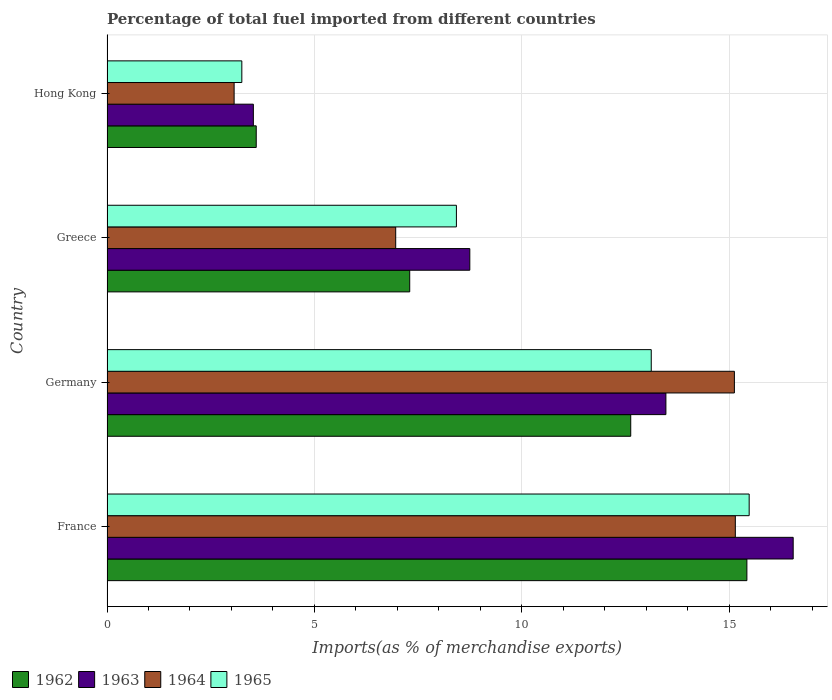How many different coloured bars are there?
Ensure brevity in your answer.  4. How many bars are there on the 2nd tick from the top?
Your answer should be very brief. 4. What is the label of the 1st group of bars from the top?
Make the answer very short. Hong Kong. What is the percentage of imports to different countries in 1965 in Germany?
Provide a short and direct response. 13.12. Across all countries, what is the maximum percentage of imports to different countries in 1965?
Make the answer very short. 15.48. Across all countries, what is the minimum percentage of imports to different countries in 1963?
Your answer should be very brief. 3.53. In which country was the percentage of imports to different countries in 1965 maximum?
Give a very brief answer. France. In which country was the percentage of imports to different countries in 1963 minimum?
Your answer should be very brief. Hong Kong. What is the total percentage of imports to different countries in 1964 in the graph?
Your answer should be compact. 40.29. What is the difference between the percentage of imports to different countries in 1962 in France and that in Hong Kong?
Provide a short and direct response. 11.83. What is the difference between the percentage of imports to different countries in 1962 in Greece and the percentage of imports to different countries in 1965 in Germany?
Keep it short and to the point. -5.82. What is the average percentage of imports to different countries in 1964 per country?
Offer a very short reply. 10.07. What is the difference between the percentage of imports to different countries in 1964 and percentage of imports to different countries in 1962 in Germany?
Ensure brevity in your answer.  2.5. In how many countries, is the percentage of imports to different countries in 1963 greater than 12 %?
Provide a succinct answer. 2. What is the ratio of the percentage of imports to different countries in 1962 in France to that in Germany?
Your answer should be very brief. 1.22. Is the percentage of imports to different countries in 1963 in Germany less than that in Hong Kong?
Make the answer very short. No. Is the difference between the percentage of imports to different countries in 1964 in France and Hong Kong greater than the difference between the percentage of imports to different countries in 1962 in France and Hong Kong?
Provide a succinct answer. Yes. What is the difference between the highest and the second highest percentage of imports to different countries in 1965?
Provide a short and direct response. 2.36. What is the difference between the highest and the lowest percentage of imports to different countries in 1964?
Your answer should be very brief. 12.08. In how many countries, is the percentage of imports to different countries in 1964 greater than the average percentage of imports to different countries in 1964 taken over all countries?
Keep it short and to the point. 2. What does the 3rd bar from the top in Germany represents?
Make the answer very short. 1963. What does the 3rd bar from the bottom in France represents?
Keep it short and to the point. 1964. How many countries are there in the graph?
Provide a short and direct response. 4. What is the difference between two consecutive major ticks on the X-axis?
Ensure brevity in your answer.  5. Are the values on the major ticks of X-axis written in scientific E-notation?
Provide a short and direct response. No. Does the graph contain any zero values?
Offer a terse response. No. Does the graph contain grids?
Offer a terse response. Yes. How many legend labels are there?
Provide a succinct answer. 4. How are the legend labels stacked?
Make the answer very short. Horizontal. What is the title of the graph?
Your answer should be very brief. Percentage of total fuel imported from different countries. Does "2012" appear as one of the legend labels in the graph?
Make the answer very short. No. What is the label or title of the X-axis?
Provide a succinct answer. Imports(as % of merchandise exports). What is the label or title of the Y-axis?
Ensure brevity in your answer.  Country. What is the Imports(as % of merchandise exports) in 1962 in France?
Your answer should be very brief. 15.42. What is the Imports(as % of merchandise exports) of 1963 in France?
Provide a short and direct response. 16.54. What is the Imports(as % of merchandise exports) in 1964 in France?
Make the answer very short. 15.14. What is the Imports(as % of merchandise exports) of 1965 in France?
Give a very brief answer. 15.48. What is the Imports(as % of merchandise exports) of 1962 in Germany?
Offer a terse response. 12.62. What is the Imports(as % of merchandise exports) in 1963 in Germany?
Your answer should be compact. 13.47. What is the Imports(as % of merchandise exports) of 1964 in Germany?
Your answer should be very brief. 15.12. What is the Imports(as % of merchandise exports) in 1965 in Germany?
Give a very brief answer. 13.12. What is the Imports(as % of merchandise exports) of 1962 in Greece?
Keep it short and to the point. 7.3. What is the Imports(as % of merchandise exports) of 1963 in Greece?
Your answer should be very brief. 8.74. What is the Imports(as % of merchandise exports) of 1964 in Greece?
Make the answer very short. 6.96. What is the Imports(as % of merchandise exports) of 1965 in Greece?
Give a very brief answer. 8.42. What is the Imports(as % of merchandise exports) of 1962 in Hong Kong?
Your response must be concise. 3.6. What is the Imports(as % of merchandise exports) of 1963 in Hong Kong?
Provide a short and direct response. 3.53. What is the Imports(as % of merchandise exports) of 1964 in Hong Kong?
Offer a terse response. 3.06. What is the Imports(as % of merchandise exports) in 1965 in Hong Kong?
Give a very brief answer. 3.25. Across all countries, what is the maximum Imports(as % of merchandise exports) in 1962?
Offer a very short reply. 15.42. Across all countries, what is the maximum Imports(as % of merchandise exports) in 1963?
Keep it short and to the point. 16.54. Across all countries, what is the maximum Imports(as % of merchandise exports) of 1964?
Provide a succinct answer. 15.14. Across all countries, what is the maximum Imports(as % of merchandise exports) of 1965?
Make the answer very short. 15.48. Across all countries, what is the minimum Imports(as % of merchandise exports) of 1962?
Your response must be concise. 3.6. Across all countries, what is the minimum Imports(as % of merchandise exports) of 1963?
Your answer should be very brief. 3.53. Across all countries, what is the minimum Imports(as % of merchandise exports) in 1964?
Give a very brief answer. 3.06. Across all countries, what is the minimum Imports(as % of merchandise exports) of 1965?
Your response must be concise. 3.25. What is the total Imports(as % of merchandise exports) in 1962 in the graph?
Your answer should be very brief. 38.94. What is the total Imports(as % of merchandise exports) of 1963 in the graph?
Your answer should be compact. 42.28. What is the total Imports(as % of merchandise exports) in 1964 in the graph?
Offer a very short reply. 40.29. What is the total Imports(as % of merchandise exports) in 1965 in the graph?
Offer a very short reply. 40.26. What is the difference between the Imports(as % of merchandise exports) in 1962 in France and that in Germany?
Provide a short and direct response. 2.8. What is the difference between the Imports(as % of merchandise exports) in 1963 in France and that in Germany?
Your answer should be very brief. 3.07. What is the difference between the Imports(as % of merchandise exports) in 1964 in France and that in Germany?
Keep it short and to the point. 0.02. What is the difference between the Imports(as % of merchandise exports) of 1965 in France and that in Germany?
Keep it short and to the point. 2.36. What is the difference between the Imports(as % of merchandise exports) in 1962 in France and that in Greece?
Your response must be concise. 8.13. What is the difference between the Imports(as % of merchandise exports) of 1963 in France and that in Greece?
Provide a succinct answer. 7.79. What is the difference between the Imports(as % of merchandise exports) in 1964 in France and that in Greece?
Ensure brevity in your answer.  8.19. What is the difference between the Imports(as % of merchandise exports) in 1965 in France and that in Greece?
Ensure brevity in your answer.  7.06. What is the difference between the Imports(as % of merchandise exports) in 1962 in France and that in Hong Kong?
Keep it short and to the point. 11.83. What is the difference between the Imports(as % of merchandise exports) in 1963 in France and that in Hong Kong?
Keep it short and to the point. 13.01. What is the difference between the Imports(as % of merchandise exports) of 1964 in France and that in Hong Kong?
Your answer should be compact. 12.08. What is the difference between the Imports(as % of merchandise exports) of 1965 in France and that in Hong Kong?
Ensure brevity in your answer.  12.23. What is the difference between the Imports(as % of merchandise exports) of 1962 in Germany and that in Greece?
Provide a short and direct response. 5.33. What is the difference between the Imports(as % of merchandise exports) of 1963 in Germany and that in Greece?
Offer a very short reply. 4.73. What is the difference between the Imports(as % of merchandise exports) in 1964 in Germany and that in Greece?
Offer a very short reply. 8.16. What is the difference between the Imports(as % of merchandise exports) of 1965 in Germany and that in Greece?
Your answer should be very brief. 4.7. What is the difference between the Imports(as % of merchandise exports) of 1962 in Germany and that in Hong Kong?
Your response must be concise. 9.03. What is the difference between the Imports(as % of merchandise exports) in 1963 in Germany and that in Hong Kong?
Keep it short and to the point. 9.94. What is the difference between the Imports(as % of merchandise exports) in 1964 in Germany and that in Hong Kong?
Give a very brief answer. 12.06. What is the difference between the Imports(as % of merchandise exports) in 1965 in Germany and that in Hong Kong?
Your response must be concise. 9.87. What is the difference between the Imports(as % of merchandise exports) of 1962 in Greece and that in Hong Kong?
Offer a terse response. 3.7. What is the difference between the Imports(as % of merchandise exports) of 1963 in Greece and that in Hong Kong?
Your answer should be very brief. 5.22. What is the difference between the Imports(as % of merchandise exports) of 1964 in Greece and that in Hong Kong?
Offer a terse response. 3.89. What is the difference between the Imports(as % of merchandise exports) in 1965 in Greece and that in Hong Kong?
Your answer should be very brief. 5.17. What is the difference between the Imports(as % of merchandise exports) in 1962 in France and the Imports(as % of merchandise exports) in 1963 in Germany?
Keep it short and to the point. 1.95. What is the difference between the Imports(as % of merchandise exports) in 1962 in France and the Imports(as % of merchandise exports) in 1964 in Germany?
Your response must be concise. 0.3. What is the difference between the Imports(as % of merchandise exports) in 1962 in France and the Imports(as % of merchandise exports) in 1965 in Germany?
Make the answer very short. 2.31. What is the difference between the Imports(as % of merchandise exports) in 1963 in France and the Imports(as % of merchandise exports) in 1964 in Germany?
Provide a succinct answer. 1.42. What is the difference between the Imports(as % of merchandise exports) of 1963 in France and the Imports(as % of merchandise exports) of 1965 in Germany?
Offer a very short reply. 3.42. What is the difference between the Imports(as % of merchandise exports) of 1964 in France and the Imports(as % of merchandise exports) of 1965 in Germany?
Provide a succinct answer. 2.03. What is the difference between the Imports(as % of merchandise exports) of 1962 in France and the Imports(as % of merchandise exports) of 1963 in Greece?
Provide a succinct answer. 6.68. What is the difference between the Imports(as % of merchandise exports) in 1962 in France and the Imports(as % of merchandise exports) in 1964 in Greece?
Provide a short and direct response. 8.46. What is the difference between the Imports(as % of merchandise exports) in 1962 in France and the Imports(as % of merchandise exports) in 1965 in Greece?
Your answer should be compact. 7. What is the difference between the Imports(as % of merchandise exports) of 1963 in France and the Imports(as % of merchandise exports) of 1964 in Greece?
Offer a very short reply. 9.58. What is the difference between the Imports(as % of merchandise exports) in 1963 in France and the Imports(as % of merchandise exports) in 1965 in Greece?
Give a very brief answer. 8.12. What is the difference between the Imports(as % of merchandise exports) of 1964 in France and the Imports(as % of merchandise exports) of 1965 in Greece?
Provide a succinct answer. 6.72. What is the difference between the Imports(as % of merchandise exports) of 1962 in France and the Imports(as % of merchandise exports) of 1963 in Hong Kong?
Provide a short and direct response. 11.89. What is the difference between the Imports(as % of merchandise exports) in 1962 in France and the Imports(as % of merchandise exports) in 1964 in Hong Kong?
Your response must be concise. 12.36. What is the difference between the Imports(as % of merchandise exports) in 1962 in France and the Imports(as % of merchandise exports) in 1965 in Hong Kong?
Ensure brevity in your answer.  12.17. What is the difference between the Imports(as % of merchandise exports) of 1963 in France and the Imports(as % of merchandise exports) of 1964 in Hong Kong?
Offer a terse response. 13.47. What is the difference between the Imports(as % of merchandise exports) of 1963 in France and the Imports(as % of merchandise exports) of 1965 in Hong Kong?
Offer a terse response. 13.29. What is the difference between the Imports(as % of merchandise exports) of 1964 in France and the Imports(as % of merchandise exports) of 1965 in Hong Kong?
Offer a very short reply. 11.89. What is the difference between the Imports(as % of merchandise exports) of 1962 in Germany and the Imports(as % of merchandise exports) of 1963 in Greece?
Offer a terse response. 3.88. What is the difference between the Imports(as % of merchandise exports) in 1962 in Germany and the Imports(as % of merchandise exports) in 1964 in Greece?
Your answer should be very brief. 5.66. What is the difference between the Imports(as % of merchandise exports) of 1962 in Germany and the Imports(as % of merchandise exports) of 1965 in Greece?
Offer a terse response. 4.2. What is the difference between the Imports(as % of merchandise exports) of 1963 in Germany and the Imports(as % of merchandise exports) of 1964 in Greece?
Keep it short and to the point. 6.51. What is the difference between the Imports(as % of merchandise exports) in 1963 in Germany and the Imports(as % of merchandise exports) in 1965 in Greece?
Ensure brevity in your answer.  5.05. What is the difference between the Imports(as % of merchandise exports) in 1964 in Germany and the Imports(as % of merchandise exports) in 1965 in Greece?
Keep it short and to the point. 6.7. What is the difference between the Imports(as % of merchandise exports) of 1962 in Germany and the Imports(as % of merchandise exports) of 1963 in Hong Kong?
Your response must be concise. 9.1. What is the difference between the Imports(as % of merchandise exports) of 1962 in Germany and the Imports(as % of merchandise exports) of 1964 in Hong Kong?
Your answer should be compact. 9.56. What is the difference between the Imports(as % of merchandise exports) of 1962 in Germany and the Imports(as % of merchandise exports) of 1965 in Hong Kong?
Your response must be concise. 9.37. What is the difference between the Imports(as % of merchandise exports) in 1963 in Germany and the Imports(as % of merchandise exports) in 1964 in Hong Kong?
Keep it short and to the point. 10.41. What is the difference between the Imports(as % of merchandise exports) of 1963 in Germany and the Imports(as % of merchandise exports) of 1965 in Hong Kong?
Give a very brief answer. 10.22. What is the difference between the Imports(as % of merchandise exports) in 1964 in Germany and the Imports(as % of merchandise exports) in 1965 in Hong Kong?
Ensure brevity in your answer.  11.87. What is the difference between the Imports(as % of merchandise exports) of 1962 in Greece and the Imports(as % of merchandise exports) of 1963 in Hong Kong?
Make the answer very short. 3.77. What is the difference between the Imports(as % of merchandise exports) of 1962 in Greece and the Imports(as % of merchandise exports) of 1964 in Hong Kong?
Provide a succinct answer. 4.23. What is the difference between the Imports(as % of merchandise exports) in 1962 in Greece and the Imports(as % of merchandise exports) in 1965 in Hong Kong?
Offer a terse response. 4.05. What is the difference between the Imports(as % of merchandise exports) of 1963 in Greece and the Imports(as % of merchandise exports) of 1964 in Hong Kong?
Offer a terse response. 5.68. What is the difference between the Imports(as % of merchandise exports) of 1963 in Greece and the Imports(as % of merchandise exports) of 1965 in Hong Kong?
Provide a succinct answer. 5.49. What is the difference between the Imports(as % of merchandise exports) in 1964 in Greece and the Imports(as % of merchandise exports) in 1965 in Hong Kong?
Provide a short and direct response. 3.71. What is the average Imports(as % of merchandise exports) of 1962 per country?
Provide a succinct answer. 9.73. What is the average Imports(as % of merchandise exports) in 1963 per country?
Your answer should be compact. 10.57. What is the average Imports(as % of merchandise exports) of 1964 per country?
Keep it short and to the point. 10.07. What is the average Imports(as % of merchandise exports) in 1965 per country?
Offer a terse response. 10.07. What is the difference between the Imports(as % of merchandise exports) in 1962 and Imports(as % of merchandise exports) in 1963 in France?
Provide a short and direct response. -1.12. What is the difference between the Imports(as % of merchandise exports) in 1962 and Imports(as % of merchandise exports) in 1964 in France?
Keep it short and to the point. 0.28. What is the difference between the Imports(as % of merchandise exports) of 1962 and Imports(as % of merchandise exports) of 1965 in France?
Your answer should be compact. -0.05. What is the difference between the Imports(as % of merchandise exports) in 1963 and Imports(as % of merchandise exports) in 1964 in France?
Keep it short and to the point. 1.39. What is the difference between the Imports(as % of merchandise exports) of 1963 and Imports(as % of merchandise exports) of 1965 in France?
Offer a terse response. 1.06. What is the difference between the Imports(as % of merchandise exports) of 1964 and Imports(as % of merchandise exports) of 1965 in France?
Ensure brevity in your answer.  -0.33. What is the difference between the Imports(as % of merchandise exports) of 1962 and Imports(as % of merchandise exports) of 1963 in Germany?
Ensure brevity in your answer.  -0.85. What is the difference between the Imports(as % of merchandise exports) of 1962 and Imports(as % of merchandise exports) of 1964 in Germany?
Keep it short and to the point. -2.5. What is the difference between the Imports(as % of merchandise exports) in 1962 and Imports(as % of merchandise exports) in 1965 in Germany?
Give a very brief answer. -0.49. What is the difference between the Imports(as % of merchandise exports) of 1963 and Imports(as % of merchandise exports) of 1964 in Germany?
Ensure brevity in your answer.  -1.65. What is the difference between the Imports(as % of merchandise exports) in 1963 and Imports(as % of merchandise exports) in 1965 in Germany?
Make the answer very short. 0.35. What is the difference between the Imports(as % of merchandise exports) of 1964 and Imports(as % of merchandise exports) of 1965 in Germany?
Your response must be concise. 2. What is the difference between the Imports(as % of merchandise exports) of 1962 and Imports(as % of merchandise exports) of 1963 in Greece?
Ensure brevity in your answer.  -1.45. What is the difference between the Imports(as % of merchandise exports) in 1962 and Imports(as % of merchandise exports) in 1964 in Greece?
Your answer should be compact. 0.34. What is the difference between the Imports(as % of merchandise exports) in 1962 and Imports(as % of merchandise exports) in 1965 in Greece?
Give a very brief answer. -1.13. What is the difference between the Imports(as % of merchandise exports) of 1963 and Imports(as % of merchandise exports) of 1964 in Greece?
Make the answer very short. 1.79. What is the difference between the Imports(as % of merchandise exports) in 1963 and Imports(as % of merchandise exports) in 1965 in Greece?
Your answer should be very brief. 0.32. What is the difference between the Imports(as % of merchandise exports) of 1964 and Imports(as % of merchandise exports) of 1965 in Greece?
Offer a very short reply. -1.46. What is the difference between the Imports(as % of merchandise exports) of 1962 and Imports(as % of merchandise exports) of 1963 in Hong Kong?
Provide a succinct answer. 0.07. What is the difference between the Imports(as % of merchandise exports) in 1962 and Imports(as % of merchandise exports) in 1964 in Hong Kong?
Offer a terse response. 0.53. What is the difference between the Imports(as % of merchandise exports) in 1962 and Imports(as % of merchandise exports) in 1965 in Hong Kong?
Keep it short and to the point. 0.35. What is the difference between the Imports(as % of merchandise exports) of 1963 and Imports(as % of merchandise exports) of 1964 in Hong Kong?
Your answer should be compact. 0.46. What is the difference between the Imports(as % of merchandise exports) of 1963 and Imports(as % of merchandise exports) of 1965 in Hong Kong?
Ensure brevity in your answer.  0.28. What is the difference between the Imports(as % of merchandise exports) in 1964 and Imports(as % of merchandise exports) in 1965 in Hong Kong?
Provide a short and direct response. -0.19. What is the ratio of the Imports(as % of merchandise exports) in 1962 in France to that in Germany?
Your response must be concise. 1.22. What is the ratio of the Imports(as % of merchandise exports) of 1963 in France to that in Germany?
Offer a terse response. 1.23. What is the ratio of the Imports(as % of merchandise exports) in 1965 in France to that in Germany?
Provide a succinct answer. 1.18. What is the ratio of the Imports(as % of merchandise exports) in 1962 in France to that in Greece?
Offer a very short reply. 2.11. What is the ratio of the Imports(as % of merchandise exports) in 1963 in France to that in Greece?
Your answer should be very brief. 1.89. What is the ratio of the Imports(as % of merchandise exports) of 1964 in France to that in Greece?
Your answer should be very brief. 2.18. What is the ratio of the Imports(as % of merchandise exports) of 1965 in France to that in Greece?
Your response must be concise. 1.84. What is the ratio of the Imports(as % of merchandise exports) of 1962 in France to that in Hong Kong?
Make the answer very short. 4.29. What is the ratio of the Imports(as % of merchandise exports) of 1963 in France to that in Hong Kong?
Your response must be concise. 4.69. What is the ratio of the Imports(as % of merchandise exports) of 1964 in France to that in Hong Kong?
Provide a short and direct response. 4.94. What is the ratio of the Imports(as % of merchandise exports) of 1965 in France to that in Hong Kong?
Make the answer very short. 4.76. What is the ratio of the Imports(as % of merchandise exports) of 1962 in Germany to that in Greece?
Keep it short and to the point. 1.73. What is the ratio of the Imports(as % of merchandise exports) of 1963 in Germany to that in Greece?
Provide a short and direct response. 1.54. What is the ratio of the Imports(as % of merchandise exports) of 1964 in Germany to that in Greece?
Your response must be concise. 2.17. What is the ratio of the Imports(as % of merchandise exports) in 1965 in Germany to that in Greece?
Give a very brief answer. 1.56. What is the ratio of the Imports(as % of merchandise exports) of 1962 in Germany to that in Hong Kong?
Provide a short and direct response. 3.51. What is the ratio of the Imports(as % of merchandise exports) in 1963 in Germany to that in Hong Kong?
Your answer should be compact. 3.82. What is the ratio of the Imports(as % of merchandise exports) of 1964 in Germany to that in Hong Kong?
Ensure brevity in your answer.  4.94. What is the ratio of the Imports(as % of merchandise exports) of 1965 in Germany to that in Hong Kong?
Provide a succinct answer. 4.04. What is the ratio of the Imports(as % of merchandise exports) of 1962 in Greece to that in Hong Kong?
Give a very brief answer. 2.03. What is the ratio of the Imports(as % of merchandise exports) of 1963 in Greece to that in Hong Kong?
Provide a succinct answer. 2.48. What is the ratio of the Imports(as % of merchandise exports) in 1964 in Greece to that in Hong Kong?
Provide a succinct answer. 2.27. What is the ratio of the Imports(as % of merchandise exports) in 1965 in Greece to that in Hong Kong?
Provide a succinct answer. 2.59. What is the difference between the highest and the second highest Imports(as % of merchandise exports) of 1962?
Offer a very short reply. 2.8. What is the difference between the highest and the second highest Imports(as % of merchandise exports) of 1963?
Offer a terse response. 3.07. What is the difference between the highest and the second highest Imports(as % of merchandise exports) of 1964?
Your response must be concise. 0.02. What is the difference between the highest and the second highest Imports(as % of merchandise exports) of 1965?
Keep it short and to the point. 2.36. What is the difference between the highest and the lowest Imports(as % of merchandise exports) of 1962?
Your response must be concise. 11.83. What is the difference between the highest and the lowest Imports(as % of merchandise exports) in 1963?
Make the answer very short. 13.01. What is the difference between the highest and the lowest Imports(as % of merchandise exports) of 1964?
Offer a very short reply. 12.08. What is the difference between the highest and the lowest Imports(as % of merchandise exports) of 1965?
Offer a very short reply. 12.23. 